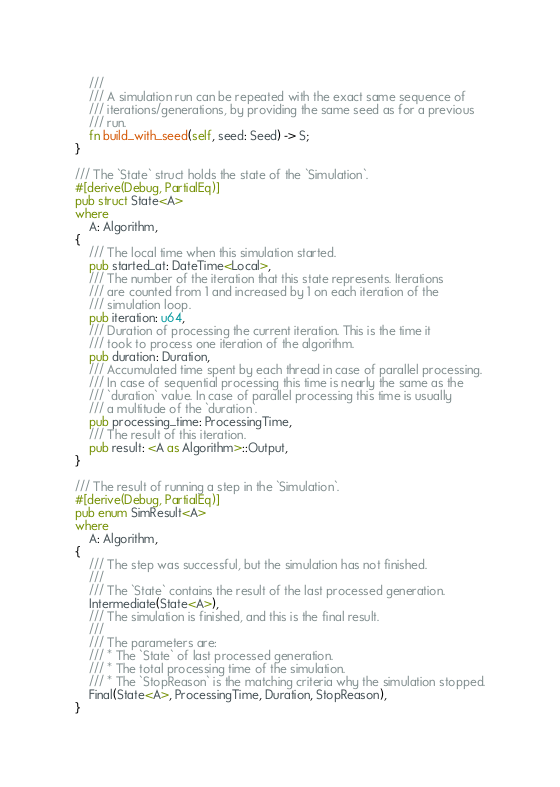Convert code to text. <code><loc_0><loc_0><loc_500><loc_500><_Rust_>    ///
    /// A simulation run can be repeated with the exact same sequence of
    /// iterations/generations, by providing the same seed as for a previous
    /// run.
    fn build_with_seed(self, seed: Seed) -> S;
}

/// The `State` struct holds the state of the `Simulation`.
#[derive(Debug, PartialEq)]
pub struct State<A>
where
    A: Algorithm,
{
    /// The local time when this simulation started.
    pub started_at: DateTime<Local>,
    /// The number of the iteration that this state represents. Iterations
    /// are counted from 1 and increased by 1 on each iteration of the
    /// simulation loop.
    pub iteration: u64,
    /// Duration of processing the current iteration. This is the time it
    /// took to process one iteration of the algorithm.
    pub duration: Duration,
    /// Accumulated time spent by each thread in case of parallel processing.
    /// In case of sequential processing this time is nearly the same as the
    /// `duration` value. In case of parallel processing this time is usually
    /// a multitude of the `duration`.
    pub processing_time: ProcessingTime,
    /// The result of this iteration.
    pub result: <A as Algorithm>::Output,
}

/// The result of running a step in the `Simulation`.
#[derive(Debug, PartialEq)]
pub enum SimResult<A>
where
    A: Algorithm,
{
    /// The step was successful, but the simulation has not finished.
    ///
    /// The `State` contains the result of the last processed generation.
    Intermediate(State<A>),
    /// The simulation is finished, and this is the final result.
    ///
    /// The parameters are:
    /// * The `State` of last processed generation.
    /// * The total processing time of the simulation.
    /// * The `StopReason` is the matching criteria why the simulation stopped.
    Final(State<A>, ProcessingTime, Duration, StopReason),
}
</code> 